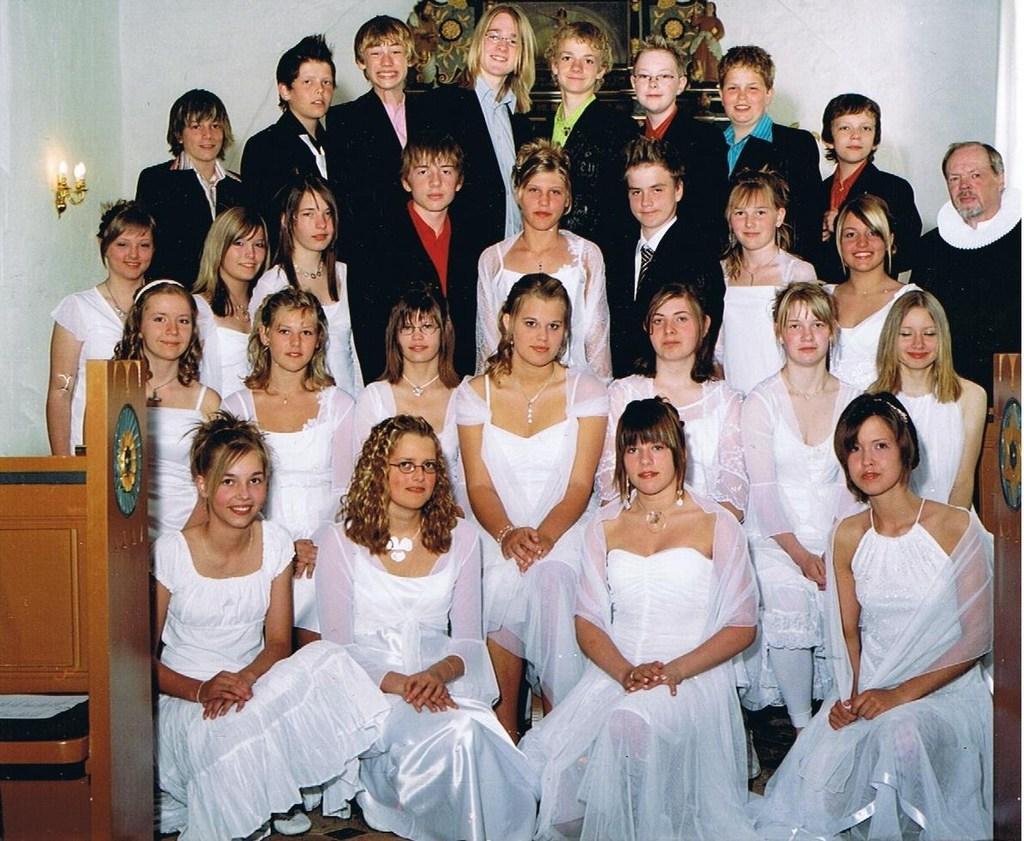How would you summarize this image in a sentence or two? This is the picture of a room. In the foreground there are group of people on knees. In the middle of the image there are group of sitting and at the back there are group of people standing. There is a light on the wall. On the left and on the right side of the image there is a table. 